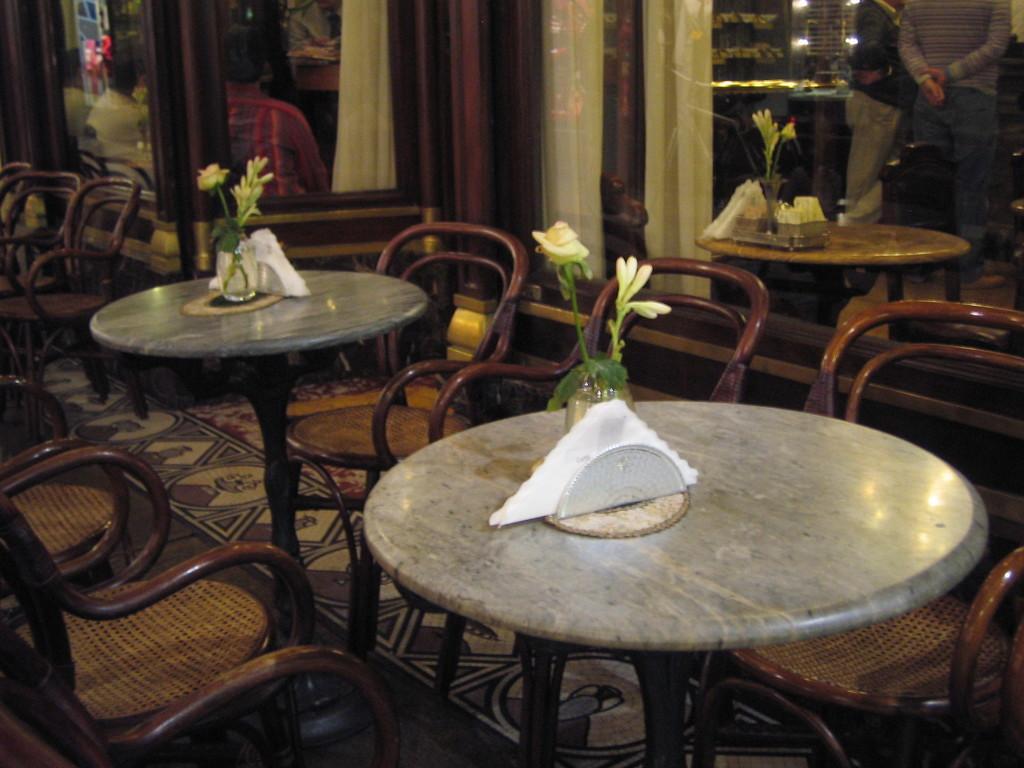Please provide a concise description of this image. In this image there are tables and chairs. On the tables there are tissues and flower vases. Behind it there are glass walls. On the other side of the walls there are curtains and a few people. There is a carpet on the floor. 